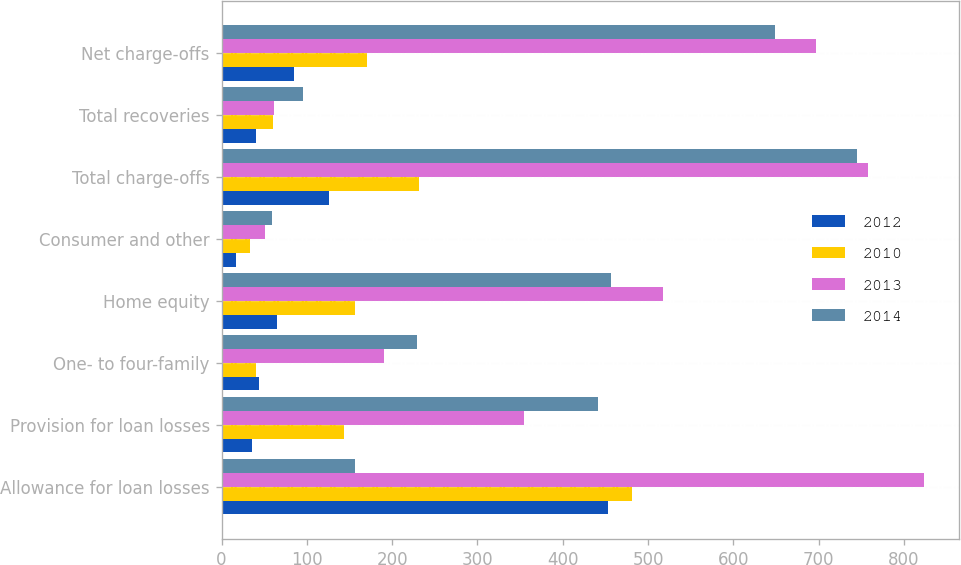<chart> <loc_0><loc_0><loc_500><loc_500><stacked_bar_chart><ecel><fcel>Allowance for loan losses<fcel>Provision for loan losses<fcel>One- to four-family<fcel>Home equity<fcel>Consumer and other<fcel>Total charge-offs<fcel>Total recoveries<fcel>Net charge-offs<nl><fcel>2012<fcel>453<fcel>36<fcel>44<fcel>65<fcel>17<fcel>126<fcel>41<fcel>85<nl><fcel>2010<fcel>481<fcel>143<fcel>41<fcel>157<fcel>33<fcel>231<fcel>60<fcel>171<nl><fcel>2013<fcel>823<fcel>355<fcel>190<fcel>517<fcel>51<fcel>758<fcel>61<fcel>697<nl><fcel>2014<fcel>157<fcel>441<fcel>229<fcel>457<fcel>59<fcel>745<fcel>96<fcel>649<nl></chart> 